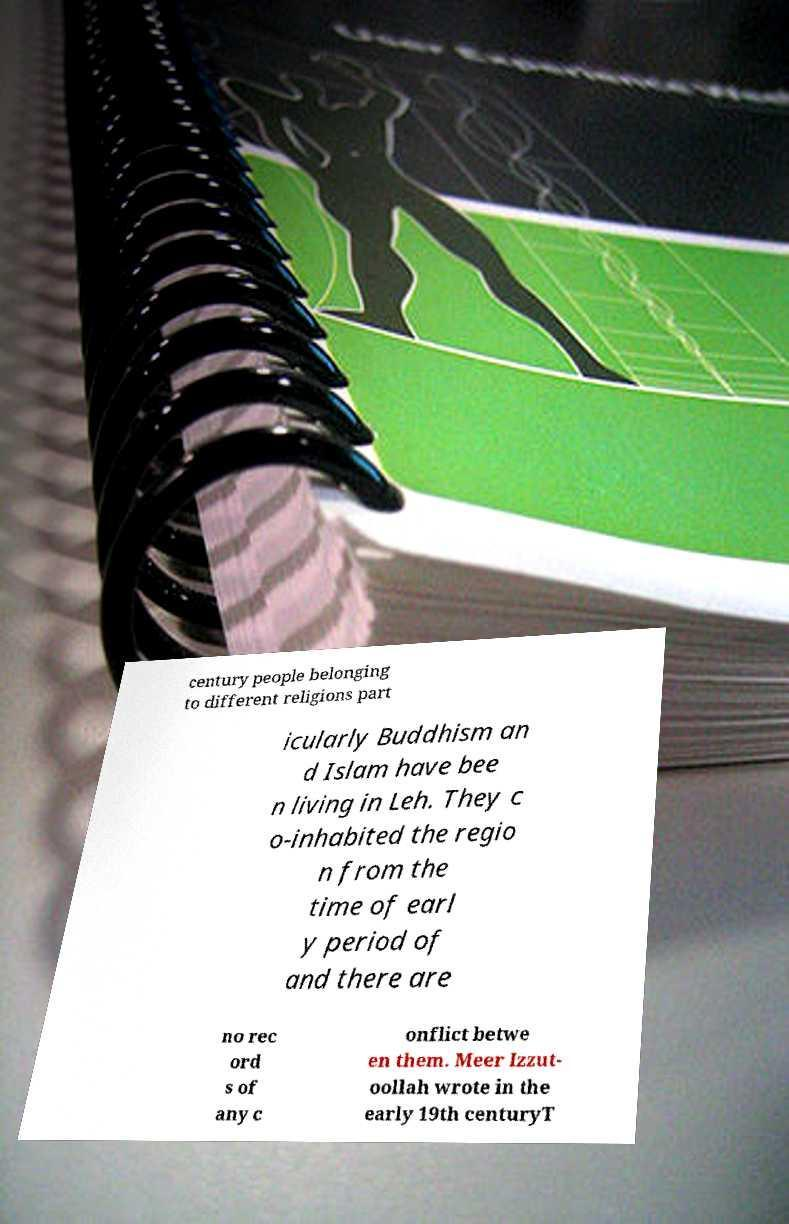Could you extract and type out the text from this image? century people belonging to different religions part icularly Buddhism an d Islam have bee n living in Leh. They c o-inhabited the regio n from the time of earl y period of and there are no rec ord s of any c onflict betwe en them. Meer Izzut- oollah wrote in the early 19th centuryT 